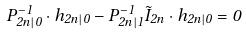Convert formula to latex. <formula><loc_0><loc_0><loc_500><loc_500>P _ { 2 n | 0 } ^ { - 1 } \cdot h _ { 2 n | 0 } - P _ { 2 n | 1 } ^ { - 1 } \tilde { I } _ { 2 n } \cdot h _ { 2 n | 0 } = 0</formula> 